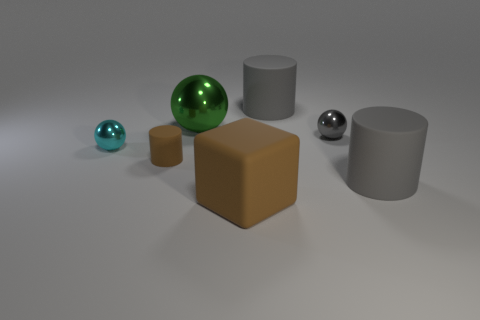Is the shape of the small gray metal thing in front of the big ball the same as the big thing that is on the left side of the block?
Your answer should be compact. Yes. What number of objects are either yellow shiny cylinders or big gray cylinders?
Provide a succinct answer. 2. What material is the small thing right of the cylinder behind the small brown thing made of?
Offer a terse response. Metal. Are there any shiny things of the same color as the block?
Ensure brevity in your answer.  No. What is the color of the matte thing that is the same size as the cyan metallic ball?
Your answer should be compact. Brown. There is a brown object in front of the gray cylinder that is right of the big gray cylinder that is behind the gray ball; what is its material?
Keep it short and to the point. Rubber. There is a small rubber object; is its color the same as the ball that is right of the large matte cube?
Ensure brevity in your answer.  No. How many things are either big rubber objects that are behind the rubber block or big rubber things that are in front of the small brown rubber cylinder?
Your answer should be compact. 3. What is the shape of the large gray object that is in front of the cylinder behind the big metallic ball?
Ensure brevity in your answer.  Cylinder. Are there any things that have the same material as the big block?
Keep it short and to the point. Yes. 